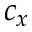<formula> <loc_0><loc_0><loc_500><loc_500>c _ { x }</formula> 